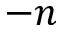Convert formula to latex. <formula><loc_0><loc_0><loc_500><loc_500>- n</formula> 